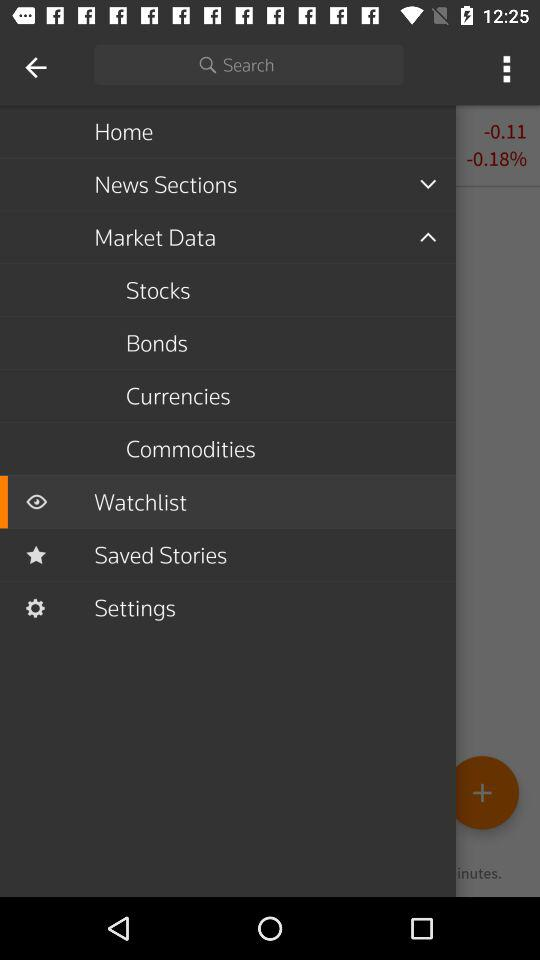How much is the change in percent?
Answer the question using a single word or phrase. -0.18% 